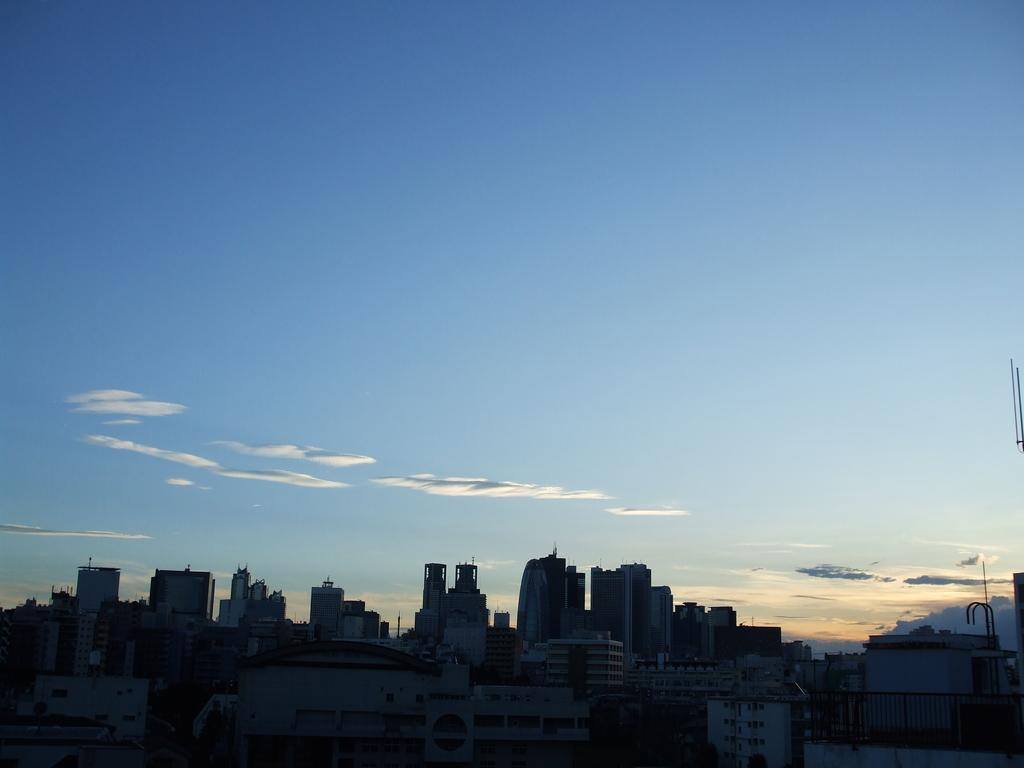What can be observed in the dark part of the image? There are buildings visible in the dark part of the image. What is visible in the background of the image? The sky is visible in the background of the image. What can be seen in the sky? Clouds are present in the sky. What type of corn is growing in the image? There is no corn present in the image. What property is being sold in the image? There is no property being sold in the image. 